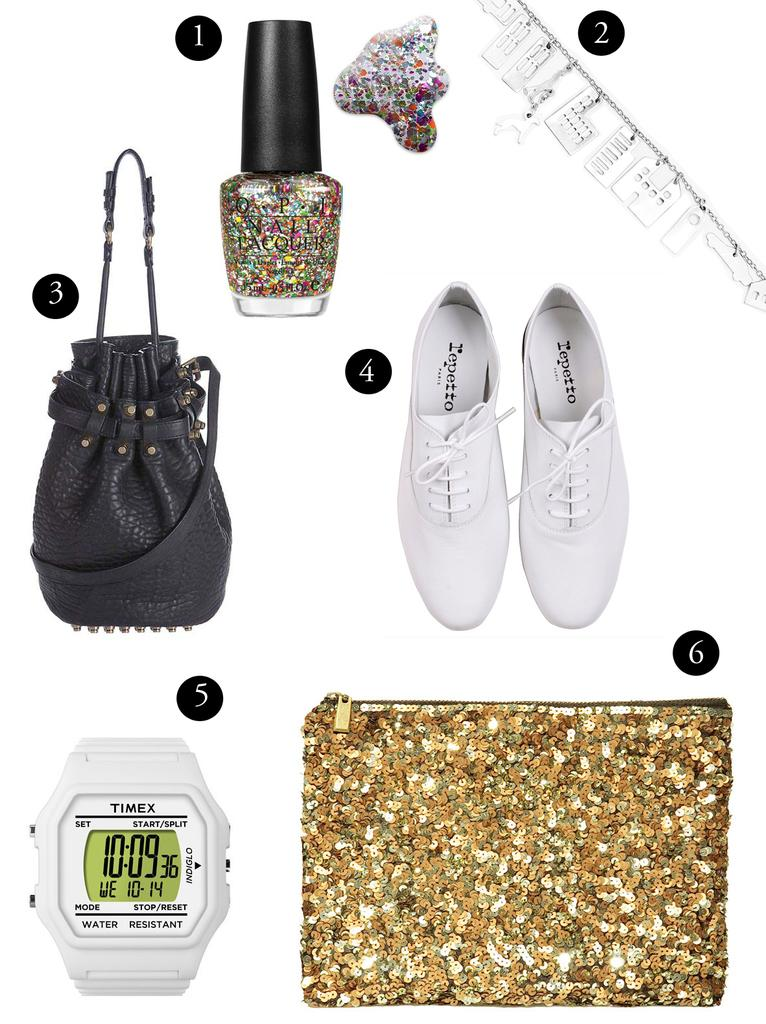What object can be seen in the image that is commonly used for carrying items? There is a bag in the image. What type of beauty product is visible in the image? Nail polish is visible in the image. What type of footwear is present in the image? There are shoes in the image. What type of timekeeping device is present in the image? A watch is present in the image. What type of additional items can be seen in the image? There are accessories in the image. Can you see a fang on any of the shoes in the image? There are no fangs present on the shoes in the image. What type of locket is hanging from the watch in the image? There is no locket present on the watch in the image. 